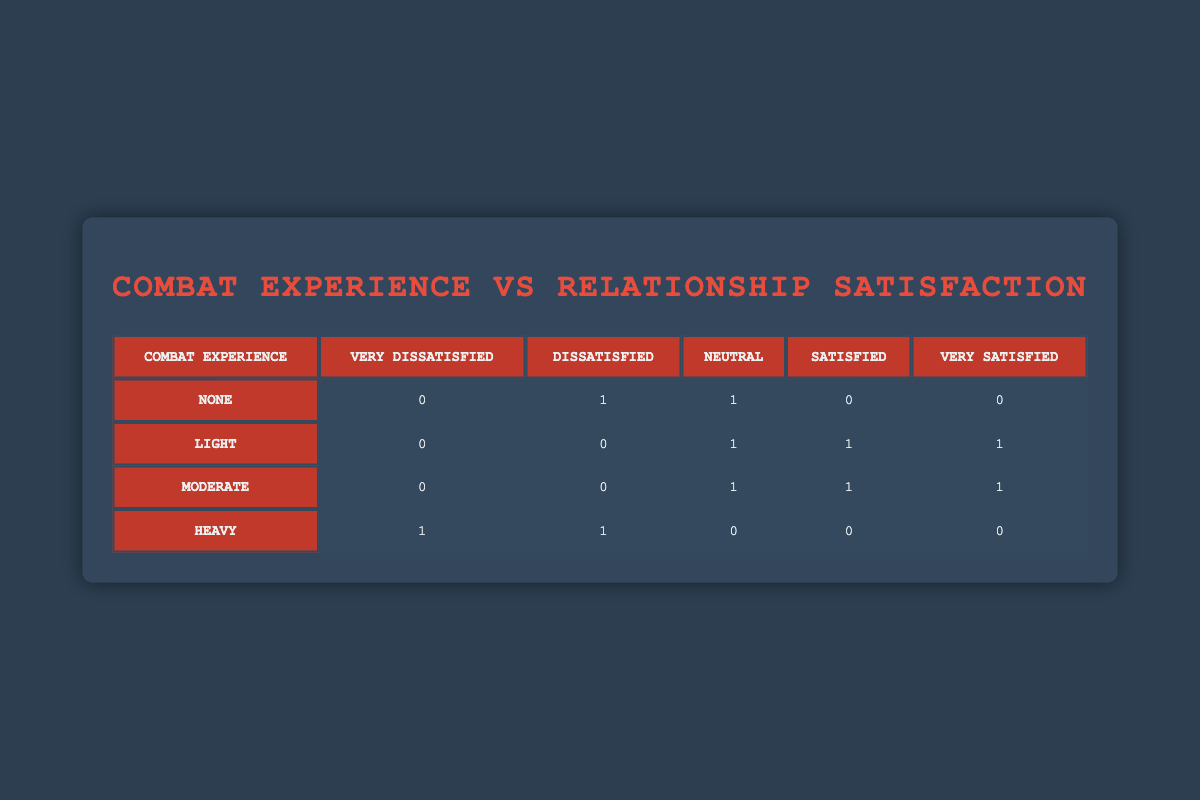What is the number of veterans who reported being very dissatisfied with their relationships? Looking at the table, we see that there is 1 veteran under the "Heavy" combat experience category who reported being very dissatisfied.
Answer: 1 How many veterans are satisfied in total across all combat experience levels? By summing the satisfied counts across the table, we see there are 1 (Light) + 1 (Moderate) = 2 veterans who are satisfied, totaling 2.
Answer: 2 Is there any veteran with heavy combat experience who reported being very satisfied? Reviewing the table, for the "Heavy" combat experience category, there are 0 veterans who reported being very satisfied.
Answer: No What is the total number of dissatisfied veterans across all combat experience levels? Adding the dissatisfied counts together, we find 1 from "None" + 1 from "Heavy" = 2 veterans who are dissatisfied in total.
Answer: 2 Which combat experience group has the highest number of very satisfied veterans? Since the "Light" and "Moderate" categories both have 1 veteran reporting being very satisfied, and there are no veterans in "None" or "Heavy" categories reporting this, both "Light" and "Moderate" share the highest count.
Answer: Light and Moderate What is the difference in the number of neutral veterans between those who have light and heavy combat experience? The Light combat experience group has 1 veteran (Neutral) and the Heavy group has 0 veterans (Neutral). Therefore, the difference is 1 - 0 = 1.
Answer: 1 How many veterans with moderate combat experience reported being dissatisfied? The table shows that there are 0 veterans in the "Moderate" group who reported being dissatisfied.
Answer: 0 Is it true that all veterans with none or heavy combat experience reported some level of dissatisfaction? Looking at the counts in the table, 1 veteran in "None" is dissatisfied and in "Heavy" 1 veteran is also dissatisfied, while the remaining in "None" and "Heavy" reported neutral or very unsatisfied. So the statement is true.
Answer: Yes What is the average level of relationship satisfaction for veterans with moderate combat experience? In the "Moderate" category, we count 1 Neutral, 1 Satisfied, and 1 Very Satisfied which corresponds to satisfaction levels of 2, 3, and 4 respectively. The average is (2 + 3 + 4) / 3 = 3.
Answer: 3 